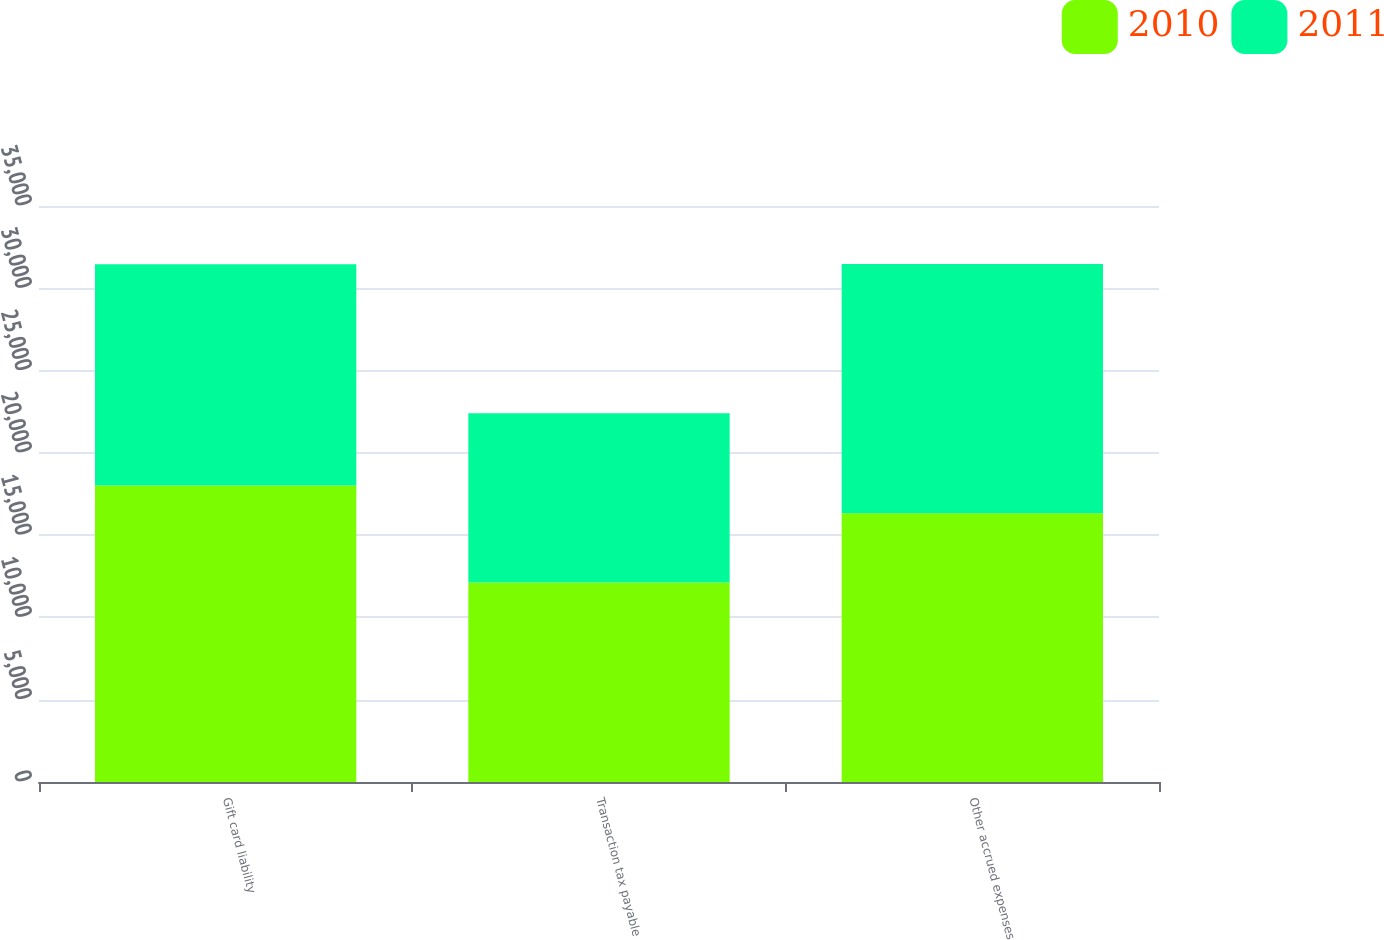<chart> <loc_0><loc_0><loc_500><loc_500><stacked_bar_chart><ecel><fcel>Gift card liability<fcel>Transaction tax payable<fcel>Other accrued expenses<nl><fcel>2010<fcel>18012<fcel>12121<fcel>16323<nl><fcel>2011<fcel>13456<fcel>10280<fcel>15156<nl></chart> 